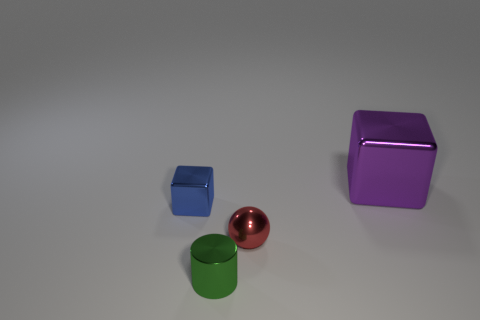Add 3 small red metallic things. How many objects exist? 7 Subtract all cylinders. How many objects are left? 3 Subtract 0 yellow blocks. How many objects are left? 4 Subtract all big gray cylinders. Subtract all metallic cylinders. How many objects are left? 3 Add 1 tiny blue metal cubes. How many tiny blue metal cubes are left? 2 Add 4 tiny red spheres. How many tiny red spheres exist? 5 